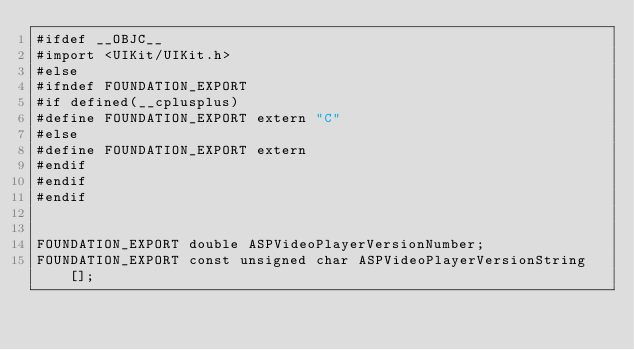Convert code to text. <code><loc_0><loc_0><loc_500><loc_500><_C_>#ifdef __OBJC__
#import <UIKit/UIKit.h>
#else
#ifndef FOUNDATION_EXPORT
#if defined(__cplusplus)
#define FOUNDATION_EXPORT extern "C"
#else
#define FOUNDATION_EXPORT extern
#endif
#endif
#endif


FOUNDATION_EXPORT double ASPVideoPlayerVersionNumber;
FOUNDATION_EXPORT const unsigned char ASPVideoPlayerVersionString[];

</code> 